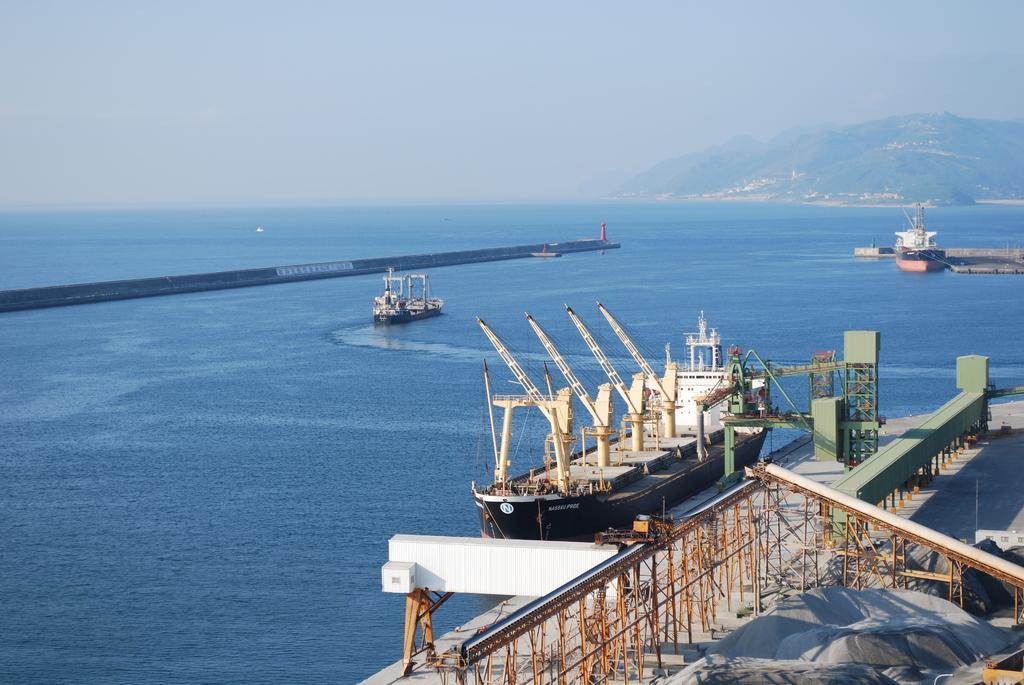Please provide a concise description of this image. There are some ships present on the surface of water as we can see in the middle of this image. There is a mountain on the right side of this image, and there is a sky at the top of this image. 